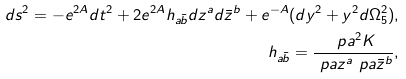<formula> <loc_0><loc_0><loc_500><loc_500>d s ^ { 2 } = - e ^ { 2 A } d t ^ { 2 } + 2 e ^ { 2 A } h _ { a \bar { b } } d z ^ { a } d \bar { z } ^ { b } + e ^ { - A } ( d y ^ { 2 } + y ^ { 2 } d \Omega _ { 5 } ^ { 2 } ) , \\ h _ { a \bar { b } } = \frac { \ p a ^ { 2 } K } { \ p a z ^ { a } \ p a { \bar { z } ^ { b } } } ,</formula> 